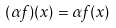Convert formula to latex. <formula><loc_0><loc_0><loc_500><loc_500>( \alpha f ) ( x ) = \alpha f ( x )</formula> 